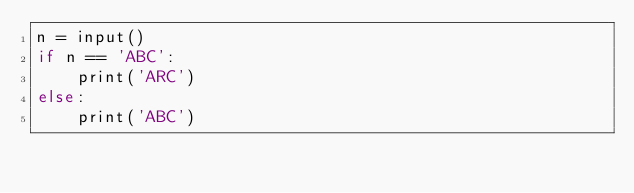Convert code to text. <code><loc_0><loc_0><loc_500><loc_500><_C_>n = input()
if n == 'ABC':
    print('ARC')
else:
    print('ABC')
</code> 